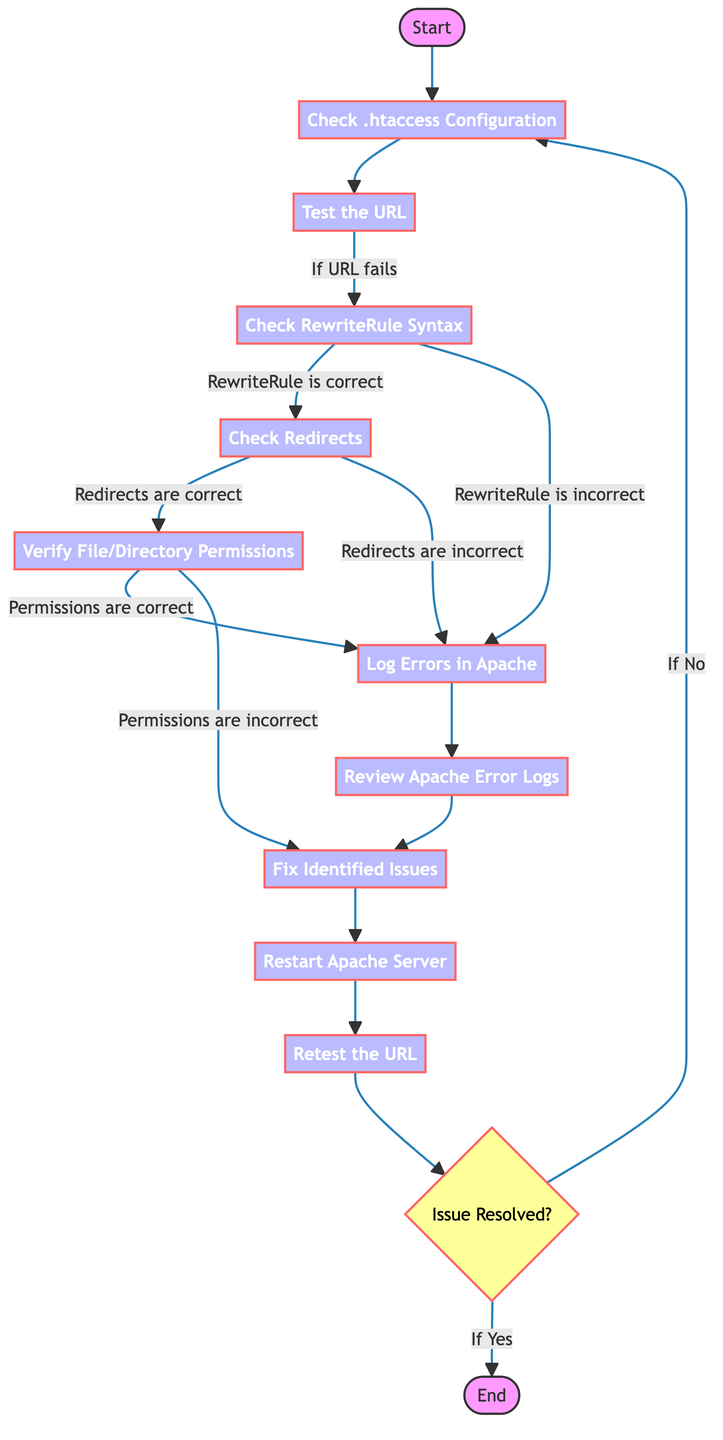What is the starting point of the flow? The flow begins at the "Start" node, which is the entry point into the process of error handling for .htaccess issues.
Answer: Start How many nodes are there in the diagram? By counting all nodes listed, we find there are 13 different nodes present, some of which represent actions while others are decision points.
Answer: 13 What action comes after checking the .htaccess configuration? After checking the .htaccess configuration, the next action is to "Test the URL," as indicated by the direct edge connecting these two nodes.
Answer: Test the URL What happens if the URL test fails? If the URL test fails, the process continues to "Check RewriteRule Syntax," according to the flowchart's pathway that responds to the failure of the URL test.
Answer: Check RewriteRule Syntax What must be checked if the rewrites are correct? If the RewriteRule is correct, the next step is to "Check Redirects," which follows logically from this node in the directed graph.
Answer: Check Redirects If the permissions are incorrect, what is the next step? When the permissions are identified as incorrect, the flow indicates that we move on to "Fix Identified Issues," which is the action taken in this scenario.
Answer: Fix Identified Issues How do we determine if the issue is resolved? The determination of whether the issue is resolved occurs at the "Issue Resolved?" decision node, which directly asks if the previous corrections have resolved the problem.
Answer: Issue Resolved? What is the process that occurs after logging errors? Following the logging of errors, the process directs to "Review Apache Error Logs," establishing a clear action to take after identifying the presence of errors.
Answer: Review Apache Error Logs What is the final action in the flowchart? The final action in this flowchart occurs at the "End" node, which signifies the conclusion of the error handling process for .htaccess issues.
Answer: End 